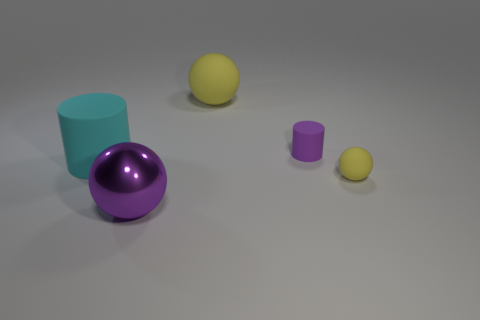Subtract all yellow spheres. How many spheres are left? 1 Subtract all cyan cubes. How many yellow balls are left? 2 Add 3 big purple objects. How many objects exist? 8 Subtract all cylinders. How many objects are left? 3 Subtract all green spheres. Subtract all gray cylinders. How many spheres are left? 3 Subtract 0 gray cylinders. How many objects are left? 5 Subtract all small red metallic objects. Subtract all big metal balls. How many objects are left? 4 Add 2 cyan cylinders. How many cyan cylinders are left? 3 Add 5 tiny brown shiny blocks. How many tiny brown shiny blocks exist? 5 